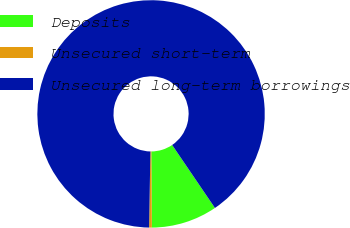Convert chart. <chart><loc_0><loc_0><loc_500><loc_500><pie_chart><fcel>Deposits<fcel>Unsecured short-term<fcel>Unsecured long-term borrowings<nl><fcel>9.38%<fcel>0.39%<fcel>90.23%<nl></chart> 